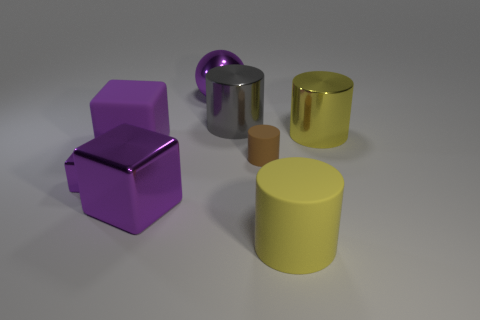How many purple blocks must be subtracted to get 1 purple blocks? 2 Add 2 small yellow metal blocks. How many objects exist? 10 Subtract all blocks. How many objects are left? 5 Add 7 large purple balls. How many large purple balls exist? 8 Subtract 2 purple cubes. How many objects are left? 6 Subtract all tiny red metal spheres. Subtract all small objects. How many objects are left? 6 Add 4 gray shiny objects. How many gray shiny objects are left? 5 